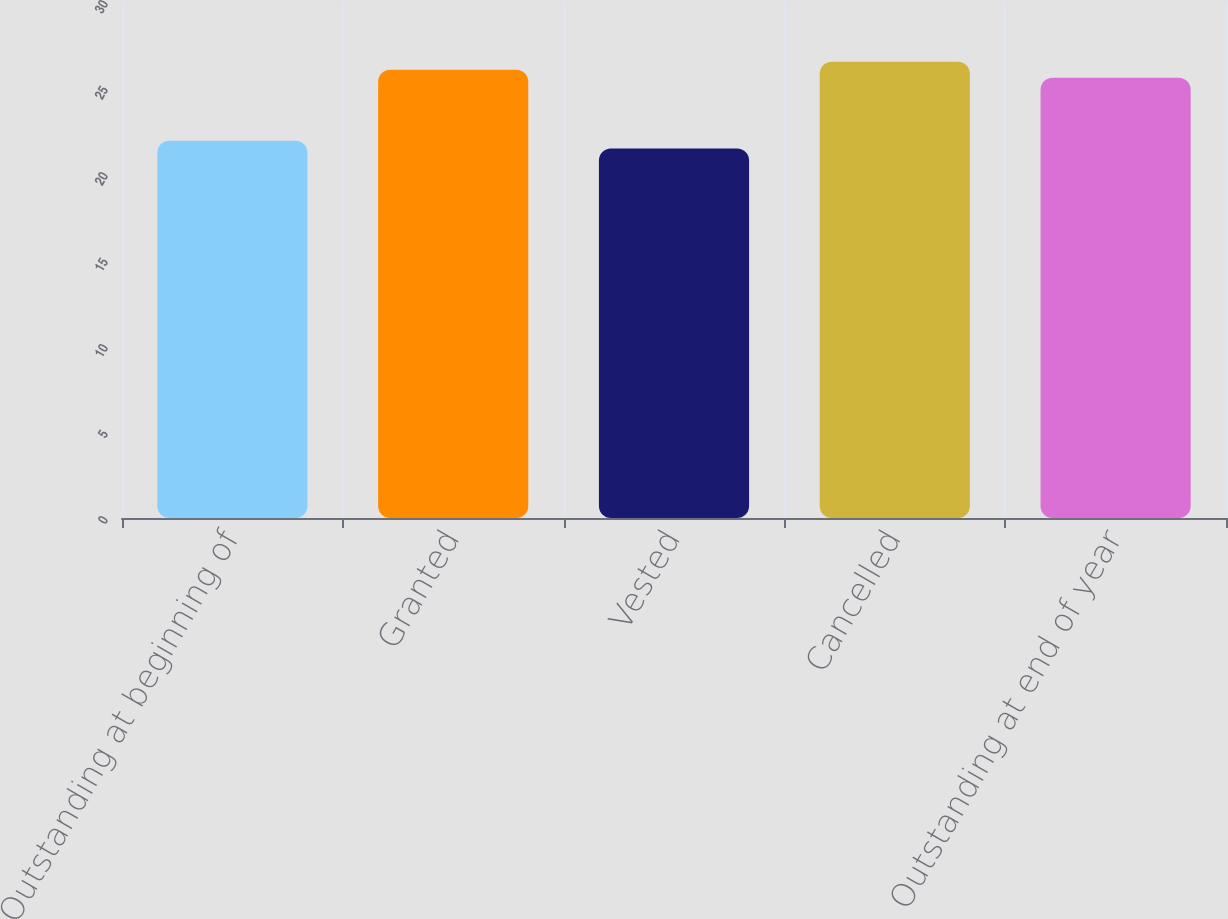<chart> <loc_0><loc_0><loc_500><loc_500><bar_chart><fcel>Outstanding at beginning of<fcel>Granted<fcel>Vested<fcel>Cancelled<fcel>Outstanding at end of year<nl><fcel>21.94<fcel>26.06<fcel>21.48<fcel>26.52<fcel>25.6<nl></chart> 